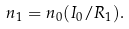<formula> <loc_0><loc_0><loc_500><loc_500>n _ { 1 } = n _ { 0 } ( I _ { 0 } / R _ { 1 } ) .</formula> 